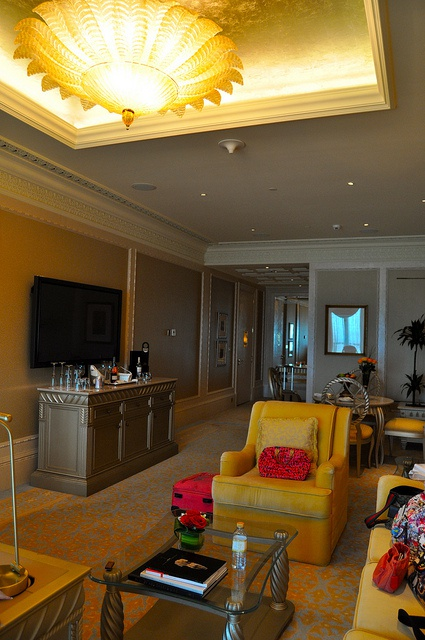Describe the objects in this image and their specific colors. I can see chair in olive and maroon tones, couch in olive and maroon tones, couch in olive, black, and tan tones, tv in olive, black, and maroon tones, and dining table in olive, maroon, and black tones in this image. 